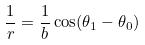<formula> <loc_0><loc_0><loc_500><loc_500>\frac { 1 } { r } = \frac { 1 } { b } \cos ( \theta _ { 1 } - \theta _ { 0 } )</formula> 